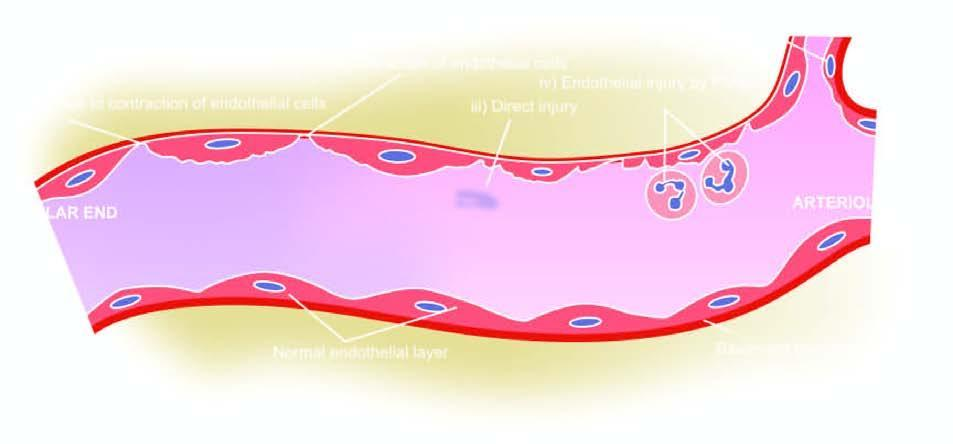what do the serial numbers in the figure correspond to in the text?
Answer the question using a single word or phrase. Five numbers 